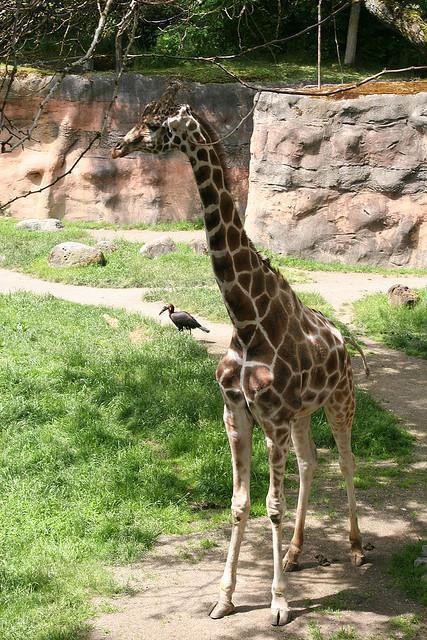How many animals are in this photo?
Give a very brief answer. 2. How many men are wearing a striped shirt?
Give a very brief answer. 0. 